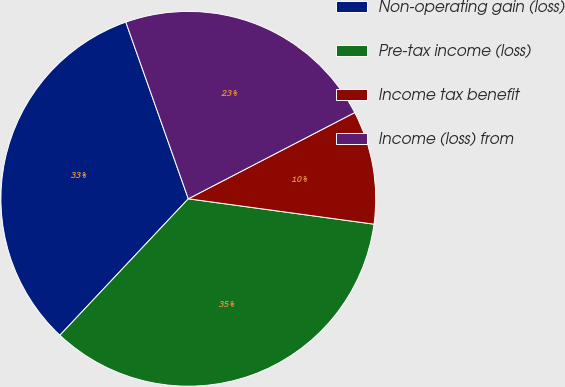<chart> <loc_0><loc_0><loc_500><loc_500><pie_chart><fcel>Non-operating gain (loss)<fcel>Pre-tax income (loss)<fcel>Income tax benefit<fcel>Income (loss) from<nl><fcel>32.57%<fcel>34.85%<fcel>9.77%<fcel>22.8%<nl></chart> 